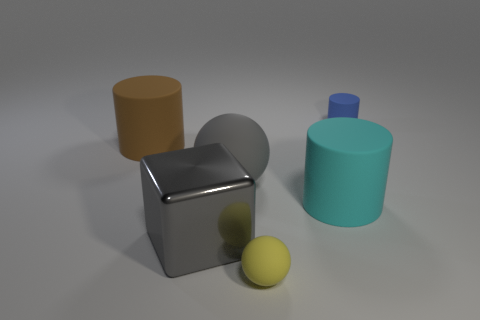Is there any other thing that has the same material as the big gray block?
Give a very brief answer. No. What number of tiny rubber objects are behind the large cylinder on the left side of the yellow ball?
Your answer should be very brief. 1. What number of other things are the same size as the gray shiny object?
Your answer should be very brief. 3. Is the metal object the same color as the big rubber sphere?
Your answer should be very brief. Yes. There is a tiny rubber object that is behind the gray block; is it the same shape as the tiny yellow thing?
Ensure brevity in your answer.  No. How many small matte objects are both behind the gray metal object and in front of the blue rubber object?
Provide a succinct answer. 0. What material is the large cyan object?
Your response must be concise. Rubber. Are there any other things that have the same color as the big shiny block?
Provide a succinct answer. Yes. Is the material of the blue object the same as the yellow thing?
Give a very brief answer. Yes. There is a tiny thing right of the tiny thing that is in front of the gray cube; how many brown things are to the right of it?
Offer a terse response. 0. 